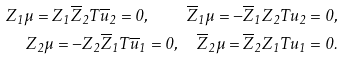Convert formula to latex. <formula><loc_0><loc_0><loc_500><loc_500>Z _ { 1 } \mu = Z _ { 1 } \overline { Z } _ { 2 } T \overline { u } _ { 2 } = 0 , \quad \overline { Z } _ { 1 } \mu = - \overline { Z } _ { 1 } Z _ { 2 } T u _ { 2 } = 0 , \\ Z _ { 2 } \mu = - Z _ { 2 } \overline { Z } _ { 1 } T \overline { u } _ { 1 } = 0 , \quad \overline { Z } _ { 2 } \mu = \overline { Z } _ { 2 } Z _ { 1 } T u _ { 1 } = 0 .</formula> 